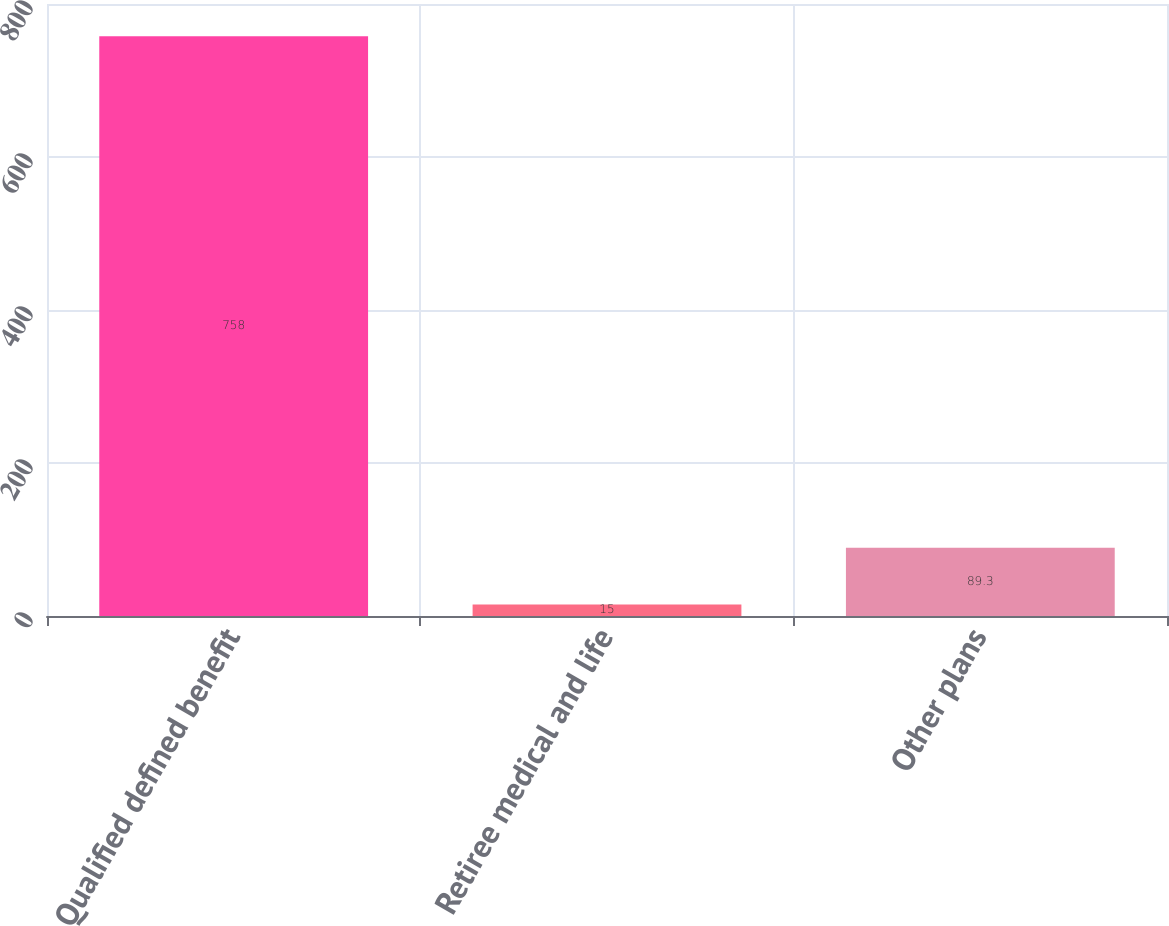Convert chart. <chart><loc_0><loc_0><loc_500><loc_500><bar_chart><fcel>Qualified defined benefit<fcel>Retiree medical and life<fcel>Other plans<nl><fcel>758<fcel>15<fcel>89.3<nl></chart> 